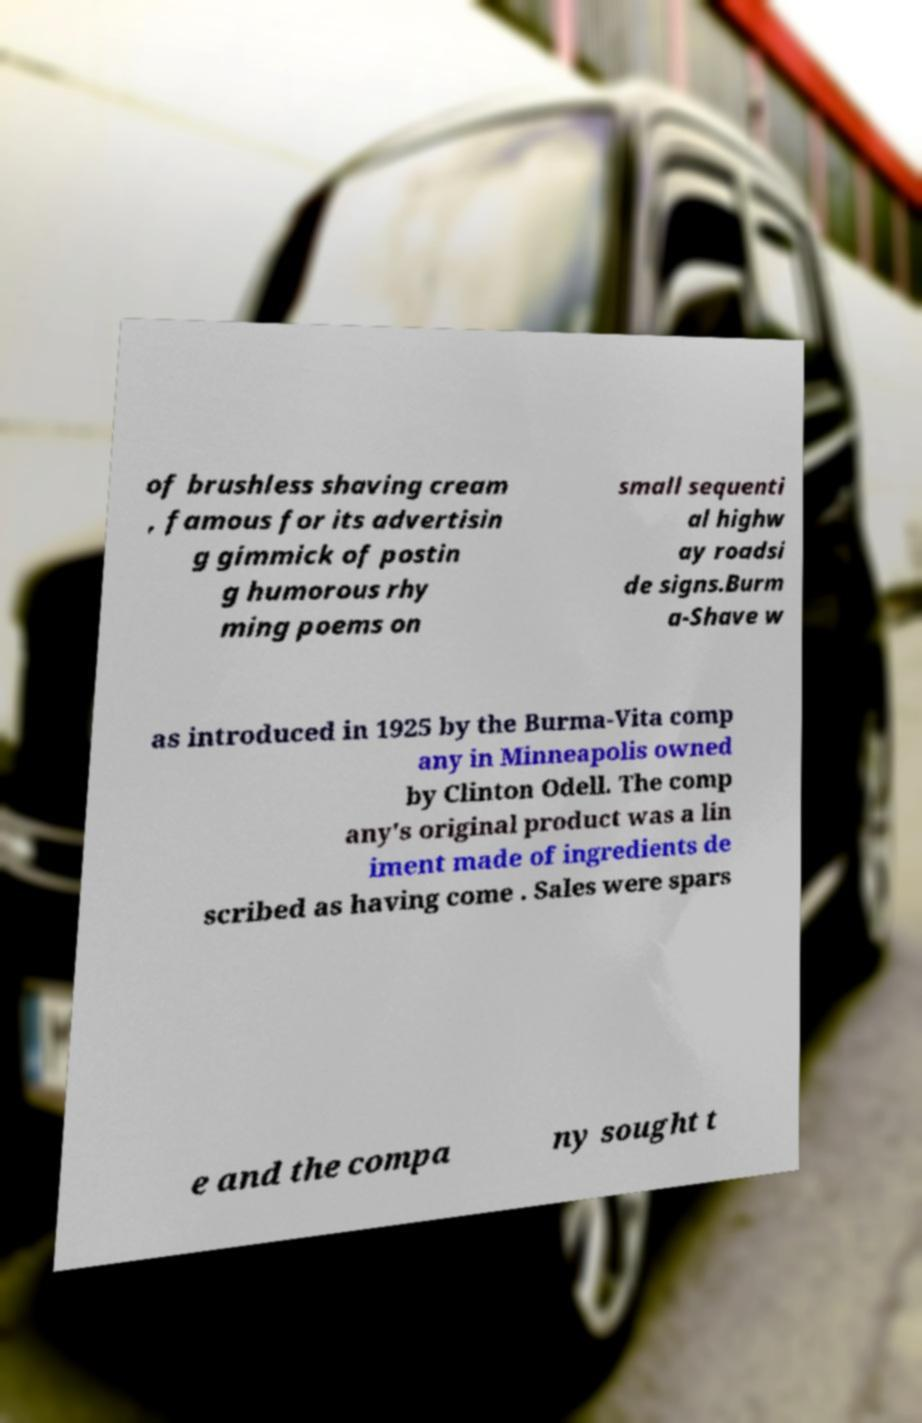Can you accurately transcribe the text from the provided image for me? of brushless shaving cream , famous for its advertisin g gimmick of postin g humorous rhy ming poems on small sequenti al highw ay roadsi de signs.Burm a-Shave w as introduced in 1925 by the Burma-Vita comp any in Minneapolis owned by Clinton Odell. The comp any's original product was a lin iment made of ingredients de scribed as having come . Sales were spars e and the compa ny sought t 